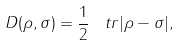Convert formula to latex. <formula><loc_0><loc_0><loc_500><loc_500>D ( \rho , \sigma ) = \frac { 1 } { 2 } \, \ t r | \rho - \sigma | ,</formula> 